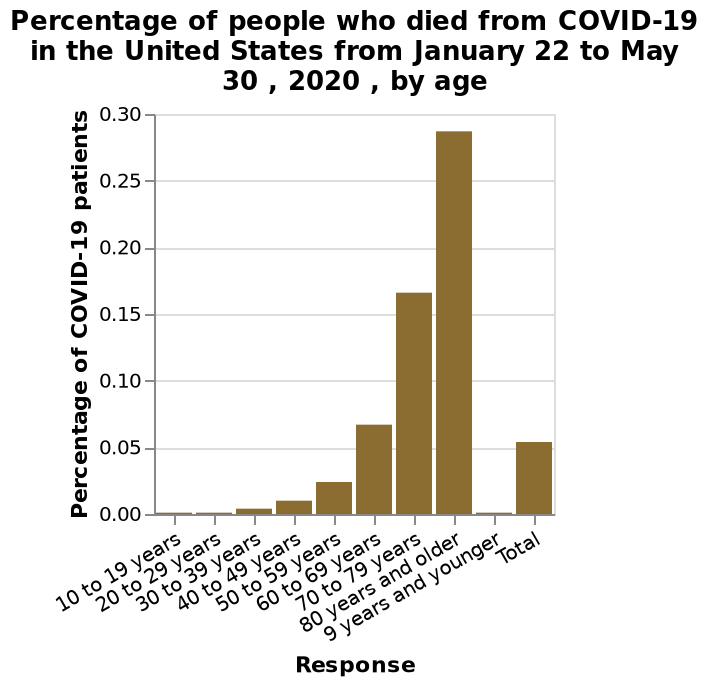<image>
What is the scale of the x-axis in the bar plot?  The scale of the x-axis in the bar plot is from 10 to 19 years and ends at the category "Total." What was the second most affected age group in terms of Covid-19 deaths?  The second most affected age group was the 70-79 years. What was the age range of the most affected age group in terms of Covid-19 deaths?  The most affected age group in terms of Covid-19 deaths had an age range of 80 years and older. 